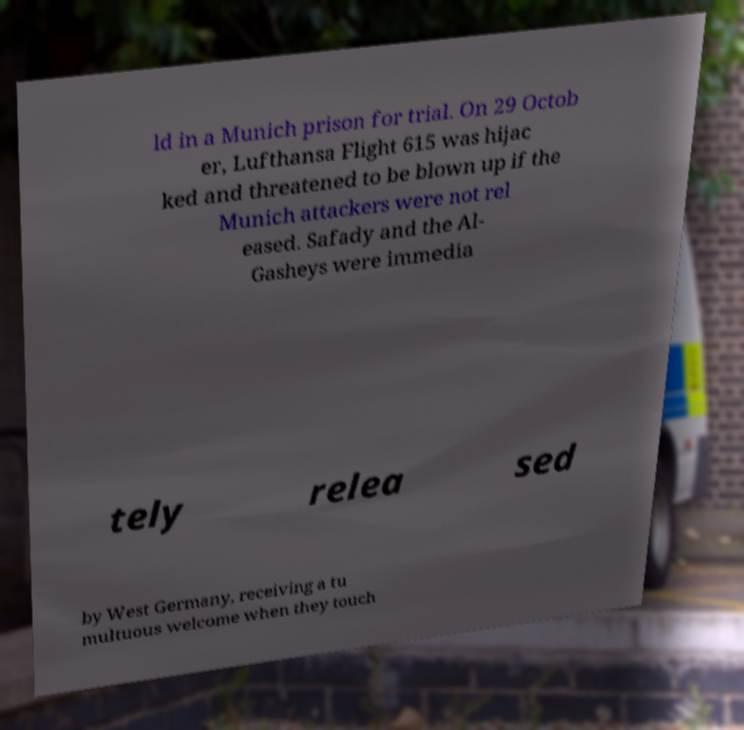Can you accurately transcribe the text from the provided image for me? ld in a Munich prison for trial. On 29 Octob er, Lufthansa Flight 615 was hijac ked and threatened to be blown up if the Munich attackers were not rel eased. Safady and the Al- Gasheys were immedia tely relea sed by West Germany, receiving a tu multuous welcome when they touch 